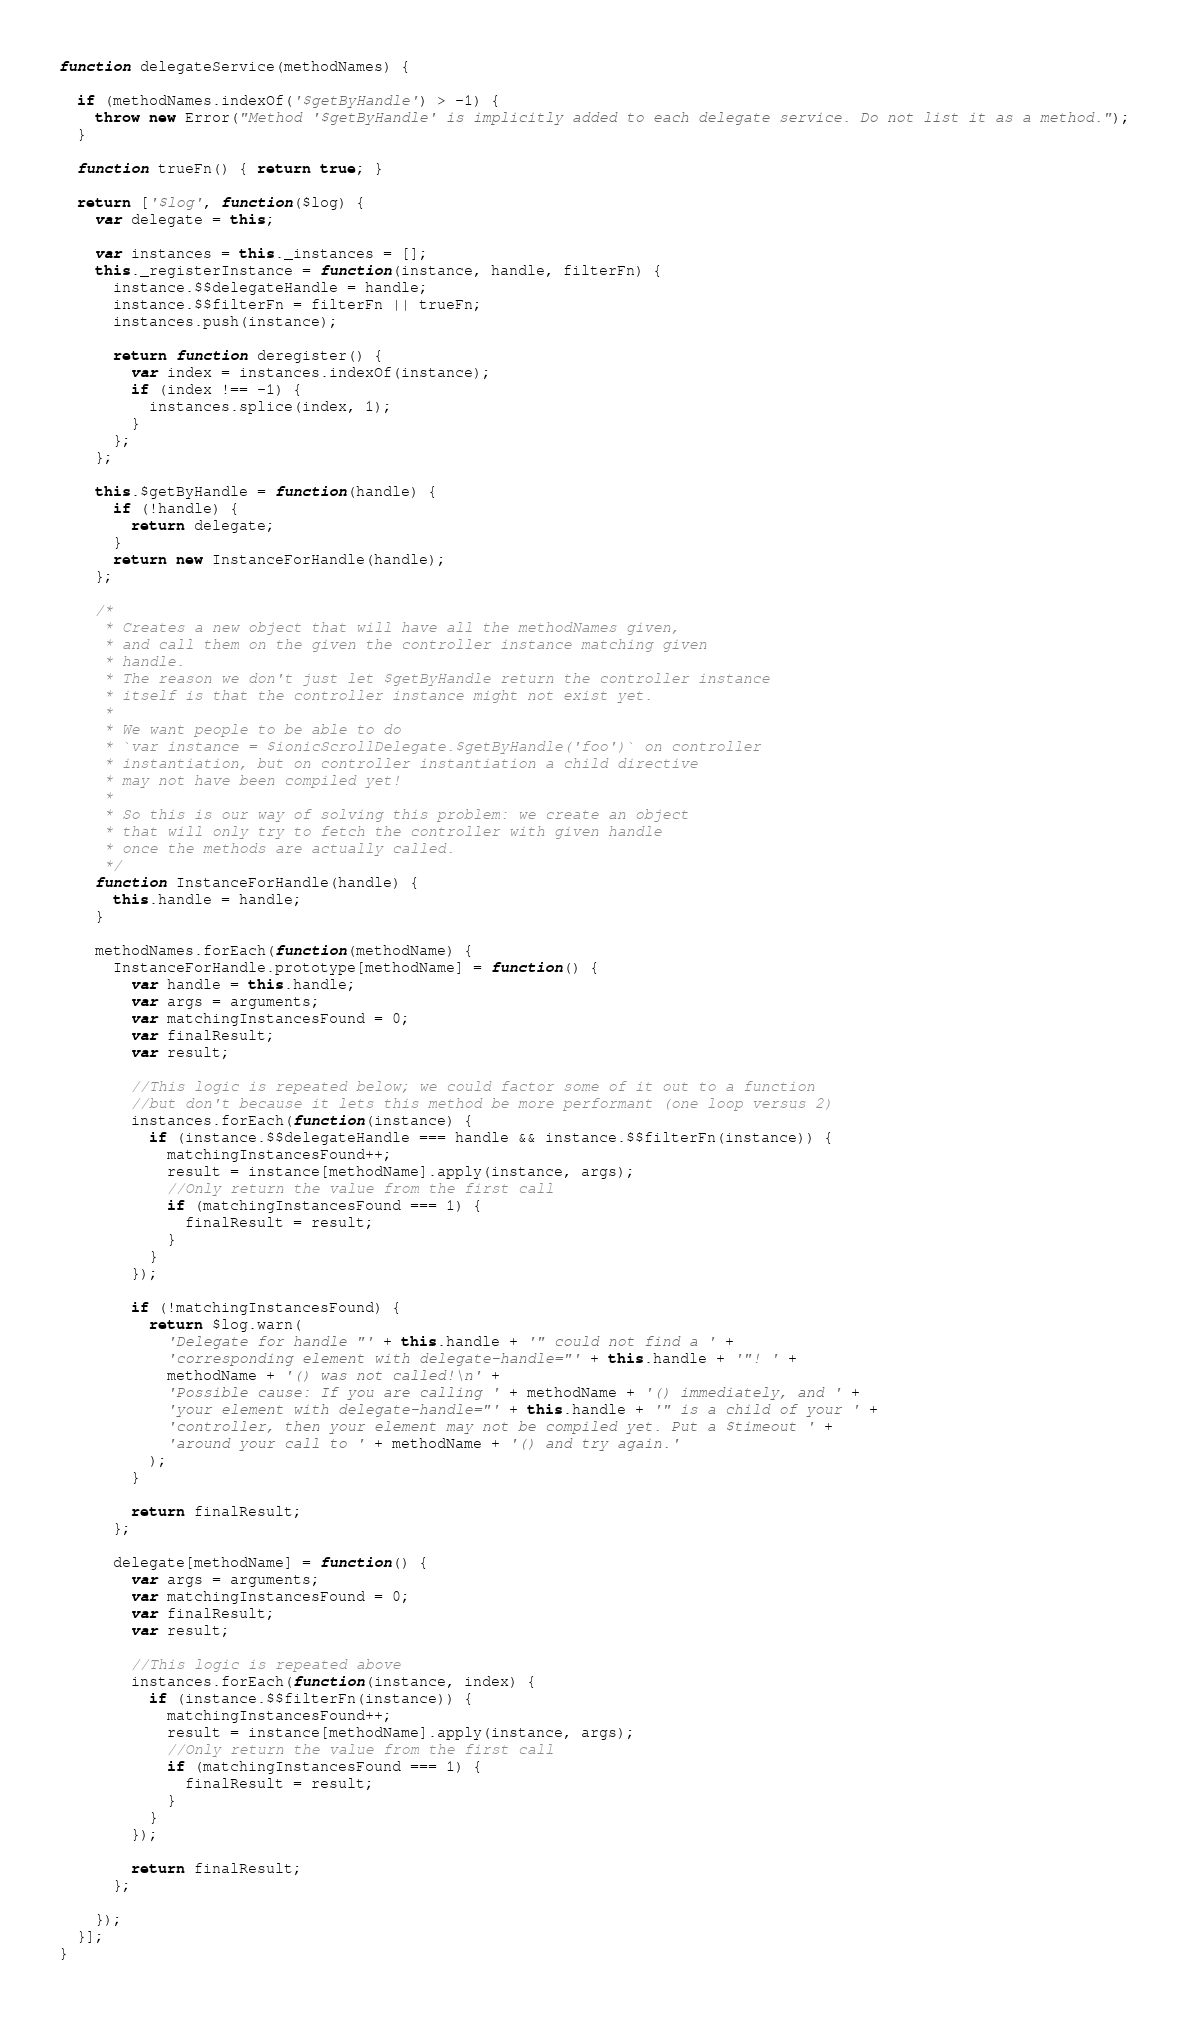Convert code to text. <code><loc_0><loc_0><loc_500><loc_500><_JavaScript_>function delegateService(methodNames) {

  if (methodNames.indexOf('$getByHandle') > -1) {
    throw new Error("Method '$getByHandle' is implicitly added to each delegate service. Do not list it as a method.");
  }

  function trueFn() { return true; }

  return ['$log', function($log) {
    var delegate = this;

    var instances = this._instances = [];
    this._registerInstance = function(instance, handle, filterFn) {
      instance.$$delegateHandle = handle;
      instance.$$filterFn = filterFn || trueFn;
      instances.push(instance);

      return function deregister() {
        var index = instances.indexOf(instance);
        if (index !== -1) {
          instances.splice(index, 1);
        }
      };
    };

    this.$getByHandle = function(handle) {
      if (!handle) {
        return delegate;
      }
      return new InstanceForHandle(handle);
    };

    /*
     * Creates a new object that will have all the methodNames given,
     * and call them on the given the controller instance matching given
     * handle.
     * The reason we don't just let $getByHandle return the controller instance
     * itself is that the controller instance might not exist yet.
     *
     * We want people to be able to do
     * `var instance = $ionicScrollDelegate.$getByHandle('foo')` on controller
     * instantiation, but on controller instantiation a child directive
     * may not have been compiled yet!
     *
     * So this is our way of solving this problem: we create an object
     * that will only try to fetch the controller with given handle
     * once the methods are actually called.
     */
    function InstanceForHandle(handle) {
      this.handle = handle;
    }

    methodNames.forEach(function(methodName) {
      InstanceForHandle.prototype[methodName] = function() {
        var handle = this.handle;
        var args = arguments;
        var matchingInstancesFound = 0;
        var finalResult;
        var result;

        //This logic is repeated below; we could factor some of it out to a function
        //but don't because it lets this method be more performant (one loop versus 2)
        instances.forEach(function(instance) {
          if (instance.$$delegateHandle === handle && instance.$$filterFn(instance)) {
            matchingInstancesFound++;
            result = instance[methodName].apply(instance, args);
            //Only return the value from the first call
            if (matchingInstancesFound === 1) {
              finalResult = result;
            }
          }
        });

        if (!matchingInstancesFound) {
          return $log.warn(
            'Delegate for handle "' + this.handle + '" could not find a ' +
            'corresponding element with delegate-handle="' + this.handle + '"! ' +
            methodName + '() was not called!\n' +
            'Possible cause: If you are calling ' + methodName + '() immediately, and ' +
            'your element with delegate-handle="' + this.handle + '" is a child of your ' +
            'controller, then your element may not be compiled yet. Put a $timeout ' +
            'around your call to ' + methodName + '() and try again.'
          );
        }

        return finalResult;
      };

      delegate[methodName] = function() {
        var args = arguments;
        var matchingInstancesFound = 0;
        var finalResult;
        var result;

        //This logic is repeated above
        instances.forEach(function(instance, index) {
          if (instance.$$filterFn(instance)) {
            matchingInstancesFound++;
            result = instance[methodName].apply(instance, args);
            //Only return the value from the first call
            if (matchingInstancesFound === 1) {
              finalResult = result;
            }
          }
        });

        return finalResult;
      };

    });
  }];
}
</code> 